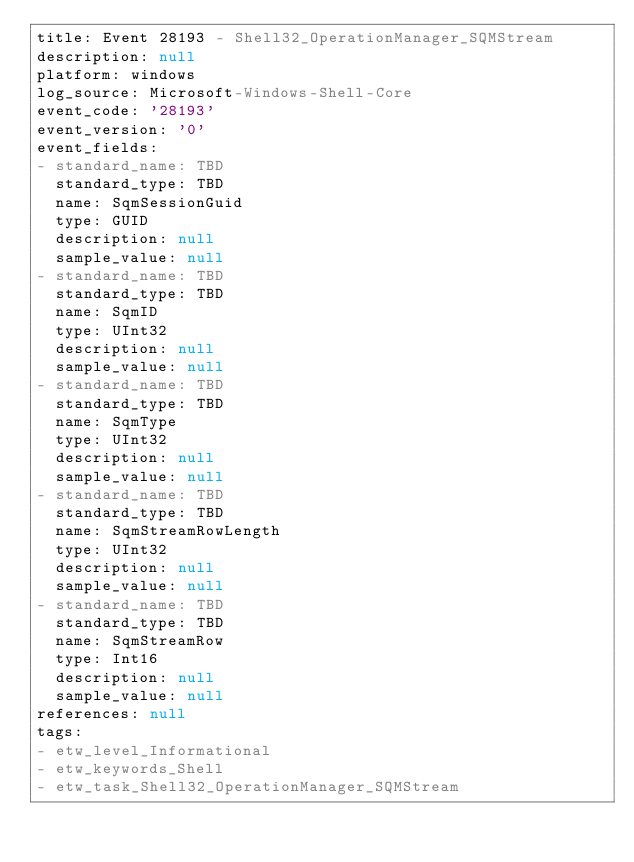<code> <loc_0><loc_0><loc_500><loc_500><_YAML_>title: Event 28193 - Shell32_OperationManager_SQMStream
description: null
platform: windows
log_source: Microsoft-Windows-Shell-Core
event_code: '28193'
event_version: '0'
event_fields:
- standard_name: TBD
  standard_type: TBD
  name: SqmSessionGuid
  type: GUID
  description: null
  sample_value: null
- standard_name: TBD
  standard_type: TBD
  name: SqmID
  type: UInt32
  description: null
  sample_value: null
- standard_name: TBD
  standard_type: TBD
  name: SqmType
  type: UInt32
  description: null
  sample_value: null
- standard_name: TBD
  standard_type: TBD
  name: SqmStreamRowLength
  type: UInt32
  description: null
  sample_value: null
- standard_name: TBD
  standard_type: TBD
  name: SqmStreamRow
  type: Int16
  description: null
  sample_value: null
references: null
tags:
- etw_level_Informational
- etw_keywords_Shell
- etw_task_Shell32_OperationManager_SQMStream
</code> 